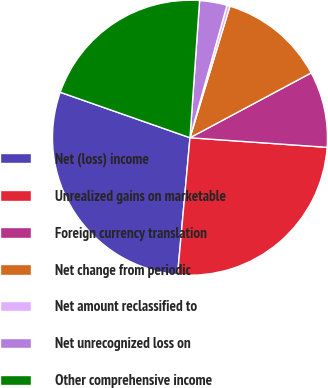<chart> <loc_0><loc_0><loc_500><loc_500><pie_chart><fcel>Net (loss) income<fcel>Unrealized gains on marketable<fcel>Foreign currency translation<fcel>Net change from periodic<fcel>Net amount reclassified to<fcel>Net unrecognized loss on<fcel>Other comprehensive income<nl><fcel>28.93%<fcel>25.33%<fcel>8.93%<fcel>12.49%<fcel>0.36%<fcel>3.22%<fcel>20.75%<nl></chart> 